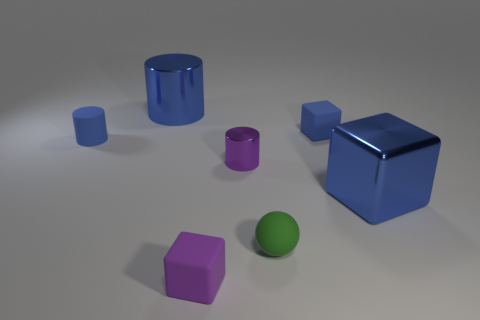Subtract all small metal cylinders. How many cylinders are left? 2 Subtract all blue spheres. How many blue cubes are left? 2 Add 1 gray rubber blocks. How many objects exist? 8 Subtract all cylinders. How many objects are left? 4 Subtract all red cylinders. Subtract all gray cubes. How many cylinders are left? 3 Subtract all purple rubber things. Subtract all tiny blue blocks. How many objects are left? 5 Add 3 small green rubber spheres. How many small green rubber spheres are left? 4 Add 7 blue metallic things. How many blue metallic things exist? 9 Subtract 1 green balls. How many objects are left? 6 